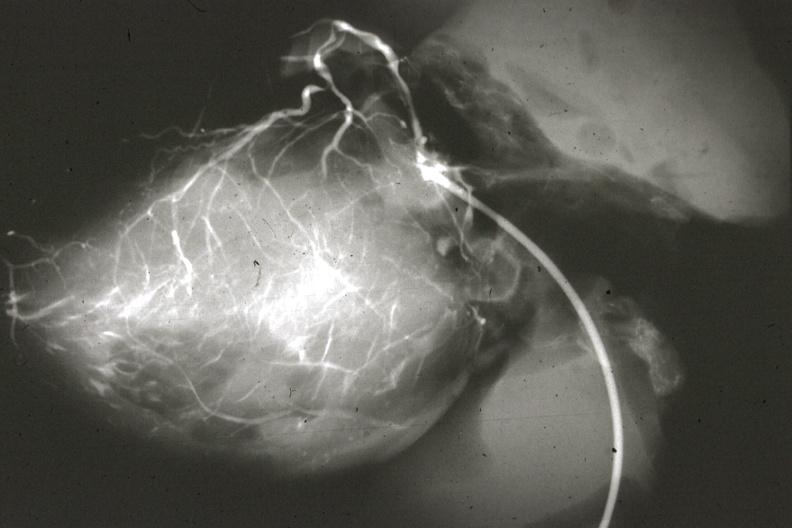s coronary artery anomalous origin left from pulmonary artery present?
Answer the question using a single word or phrase. Yes 